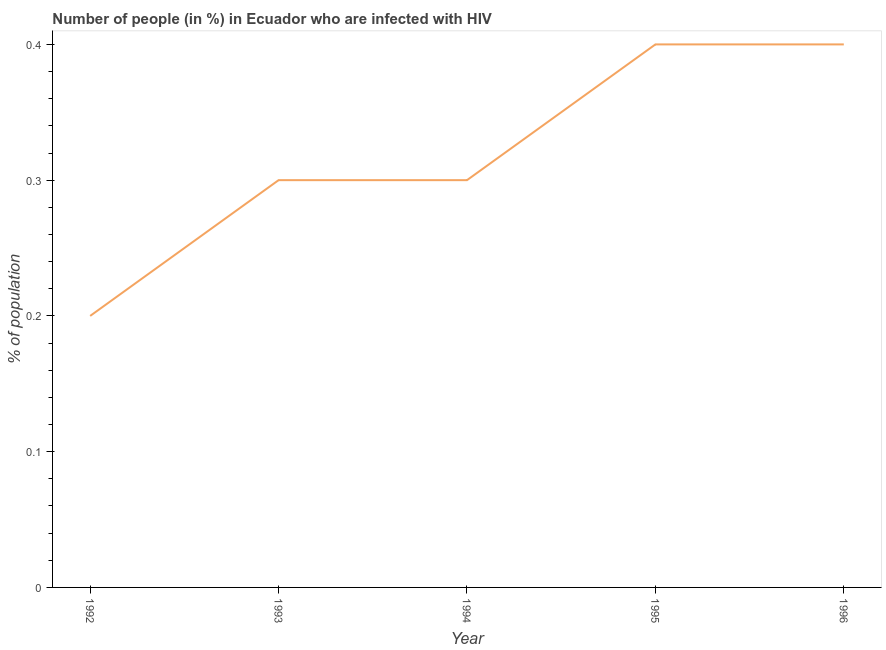Across all years, what is the minimum number of people infected with hiv?
Offer a terse response. 0.2. In which year was the number of people infected with hiv minimum?
Provide a succinct answer. 1992. What is the sum of the number of people infected with hiv?
Your response must be concise. 1.6. What is the average number of people infected with hiv per year?
Make the answer very short. 0.32. What is the ratio of the number of people infected with hiv in 1993 to that in 1994?
Provide a short and direct response. 1. What is the difference between the highest and the second highest number of people infected with hiv?
Your response must be concise. 0. What is the difference between the highest and the lowest number of people infected with hiv?
Your response must be concise. 0.2. Does the number of people infected with hiv monotonically increase over the years?
Provide a succinct answer. No. How many lines are there?
Provide a succinct answer. 1. How many years are there in the graph?
Provide a succinct answer. 5. What is the difference between two consecutive major ticks on the Y-axis?
Give a very brief answer. 0.1. Are the values on the major ticks of Y-axis written in scientific E-notation?
Provide a short and direct response. No. Does the graph contain any zero values?
Provide a succinct answer. No. Does the graph contain grids?
Keep it short and to the point. No. What is the title of the graph?
Your response must be concise. Number of people (in %) in Ecuador who are infected with HIV. What is the label or title of the X-axis?
Give a very brief answer. Year. What is the label or title of the Y-axis?
Your answer should be very brief. % of population. What is the % of population in 1992?
Your answer should be compact. 0.2. What is the % of population of 1993?
Keep it short and to the point. 0.3. What is the % of population of 1994?
Provide a succinct answer. 0.3. What is the % of population in 1995?
Offer a very short reply. 0.4. What is the % of population in 1996?
Give a very brief answer. 0.4. What is the difference between the % of population in 1992 and 1996?
Ensure brevity in your answer.  -0.2. What is the difference between the % of population in 1993 and 1995?
Give a very brief answer. -0.1. What is the difference between the % of population in 1993 and 1996?
Give a very brief answer. -0.1. What is the difference between the % of population in 1994 and 1995?
Your answer should be very brief. -0.1. What is the difference between the % of population in 1995 and 1996?
Offer a very short reply. 0. What is the ratio of the % of population in 1992 to that in 1993?
Offer a very short reply. 0.67. What is the ratio of the % of population in 1992 to that in 1994?
Keep it short and to the point. 0.67. What is the ratio of the % of population in 1992 to that in 1995?
Provide a short and direct response. 0.5. What is the ratio of the % of population in 1993 to that in 1994?
Ensure brevity in your answer.  1. What is the ratio of the % of population in 1993 to that in 1995?
Offer a very short reply. 0.75. What is the ratio of the % of population in 1994 to that in 1995?
Offer a very short reply. 0.75. What is the ratio of the % of population in 1995 to that in 1996?
Make the answer very short. 1. 